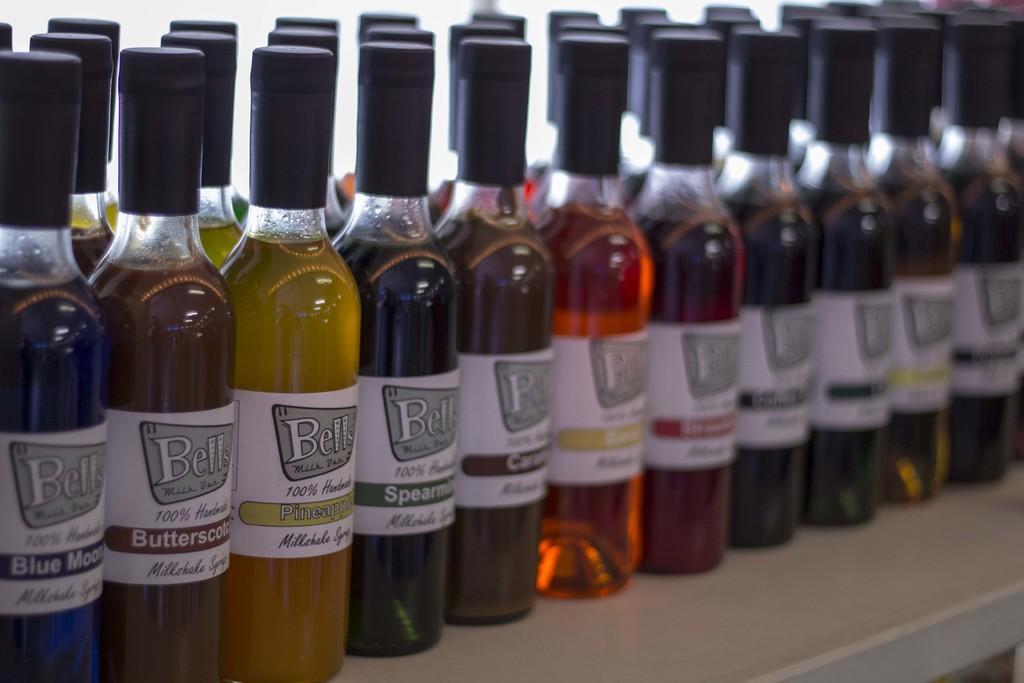How would you summarize this image in a sentence or two? There are few bottles with colorful liquid in each bottle on a table. 